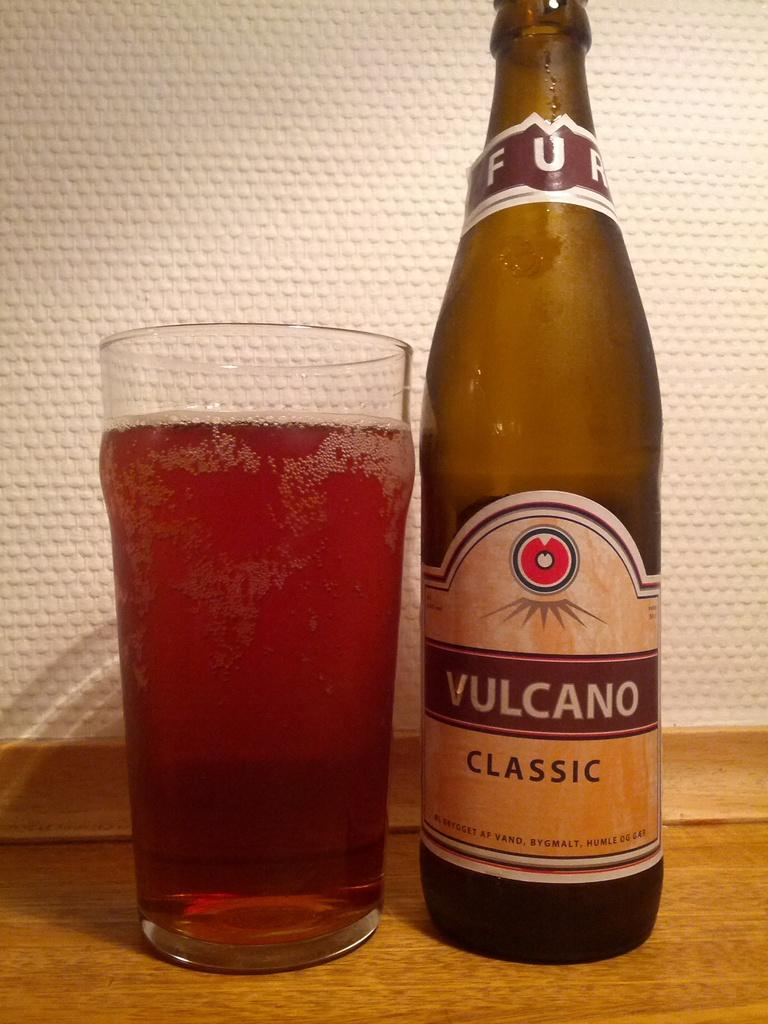<image>
Give a short and clear explanation of the subsequent image. A bottle of beer next to a glass of beer, the bottle reading Vulcano classic. 